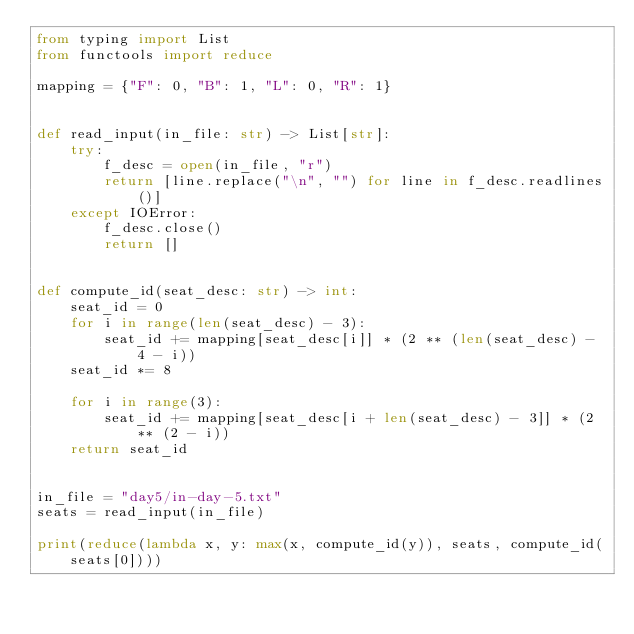Convert code to text. <code><loc_0><loc_0><loc_500><loc_500><_Python_>from typing import List
from functools import reduce

mapping = {"F": 0, "B": 1, "L": 0, "R": 1}


def read_input(in_file: str) -> List[str]:
    try:
        f_desc = open(in_file, "r")
        return [line.replace("\n", "") for line in f_desc.readlines()]
    except IOError:
        f_desc.close()
        return []


def compute_id(seat_desc: str) -> int:
    seat_id = 0
    for i in range(len(seat_desc) - 3):
        seat_id += mapping[seat_desc[i]] * (2 ** (len(seat_desc) - 4 - i))
    seat_id *= 8

    for i in range(3):
        seat_id += mapping[seat_desc[i + len(seat_desc) - 3]] * (2 ** (2 - i))
    return seat_id


in_file = "day5/in-day-5.txt"
seats = read_input(in_file)

print(reduce(lambda x, y: max(x, compute_id(y)), seats, compute_id(seats[0])))
</code> 